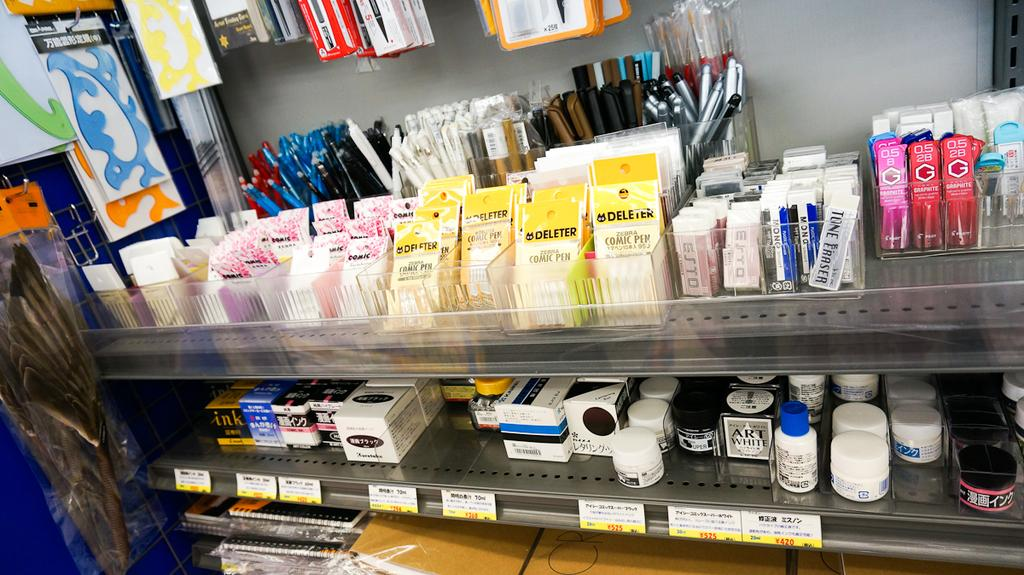<image>
Render a clear and concise summary of the photo. Two shelves containing art supplies, including Art White. 